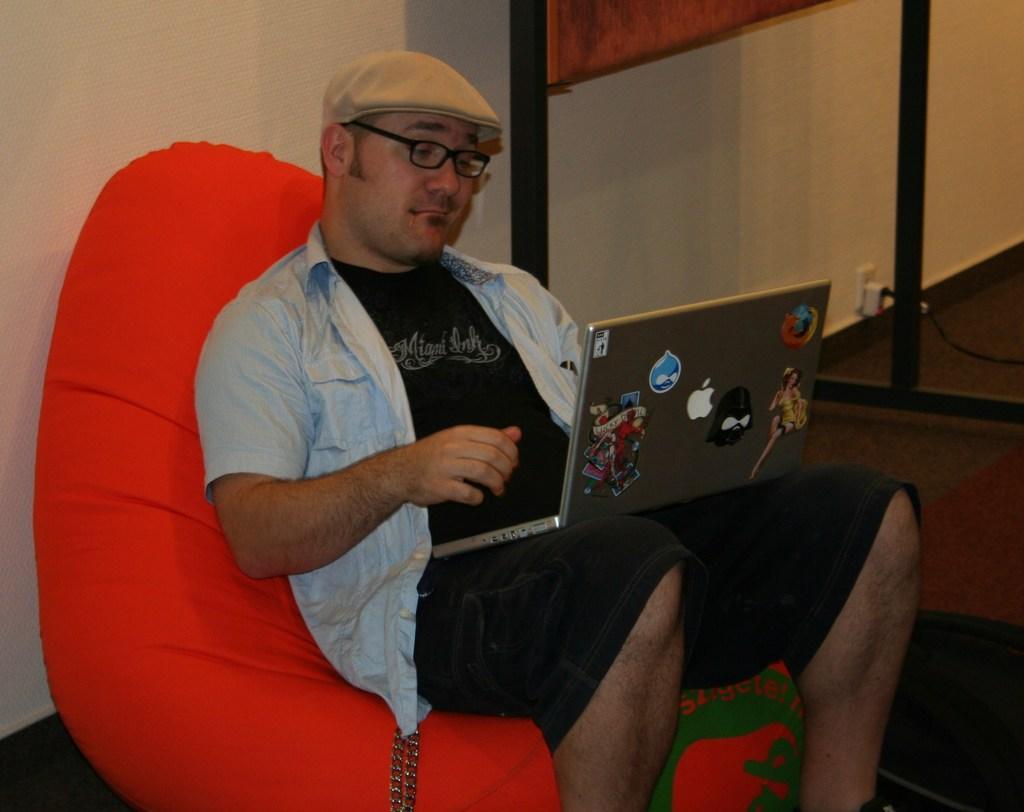Please provide a concise description of this image. In this image we can see a person wearing a t shirt ,spectacles and a brown cap is sitting on a chair placed on the ground. Holding a laptop on his legs. In the background,we can see a glass door. 